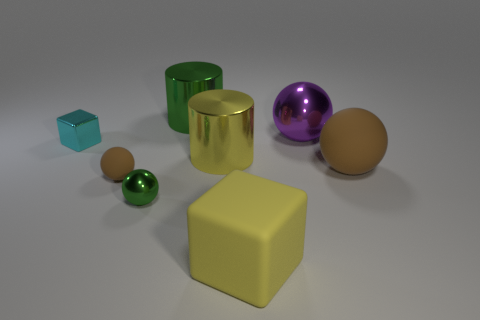Subtract all large brown matte balls. How many balls are left? 3 Add 2 small red shiny cylinders. How many objects exist? 10 Subtract all blocks. How many objects are left? 6 Subtract 1 cylinders. How many cylinders are left? 1 Subtract all yellow blocks. How many blocks are left? 1 Subtract all yellow cylinders. How many red blocks are left? 0 Subtract all small blue matte cylinders. Subtract all big yellow shiny cylinders. How many objects are left? 7 Add 1 metal blocks. How many metal blocks are left? 2 Add 8 big red rubber things. How many big red rubber things exist? 8 Subtract 1 purple balls. How many objects are left? 7 